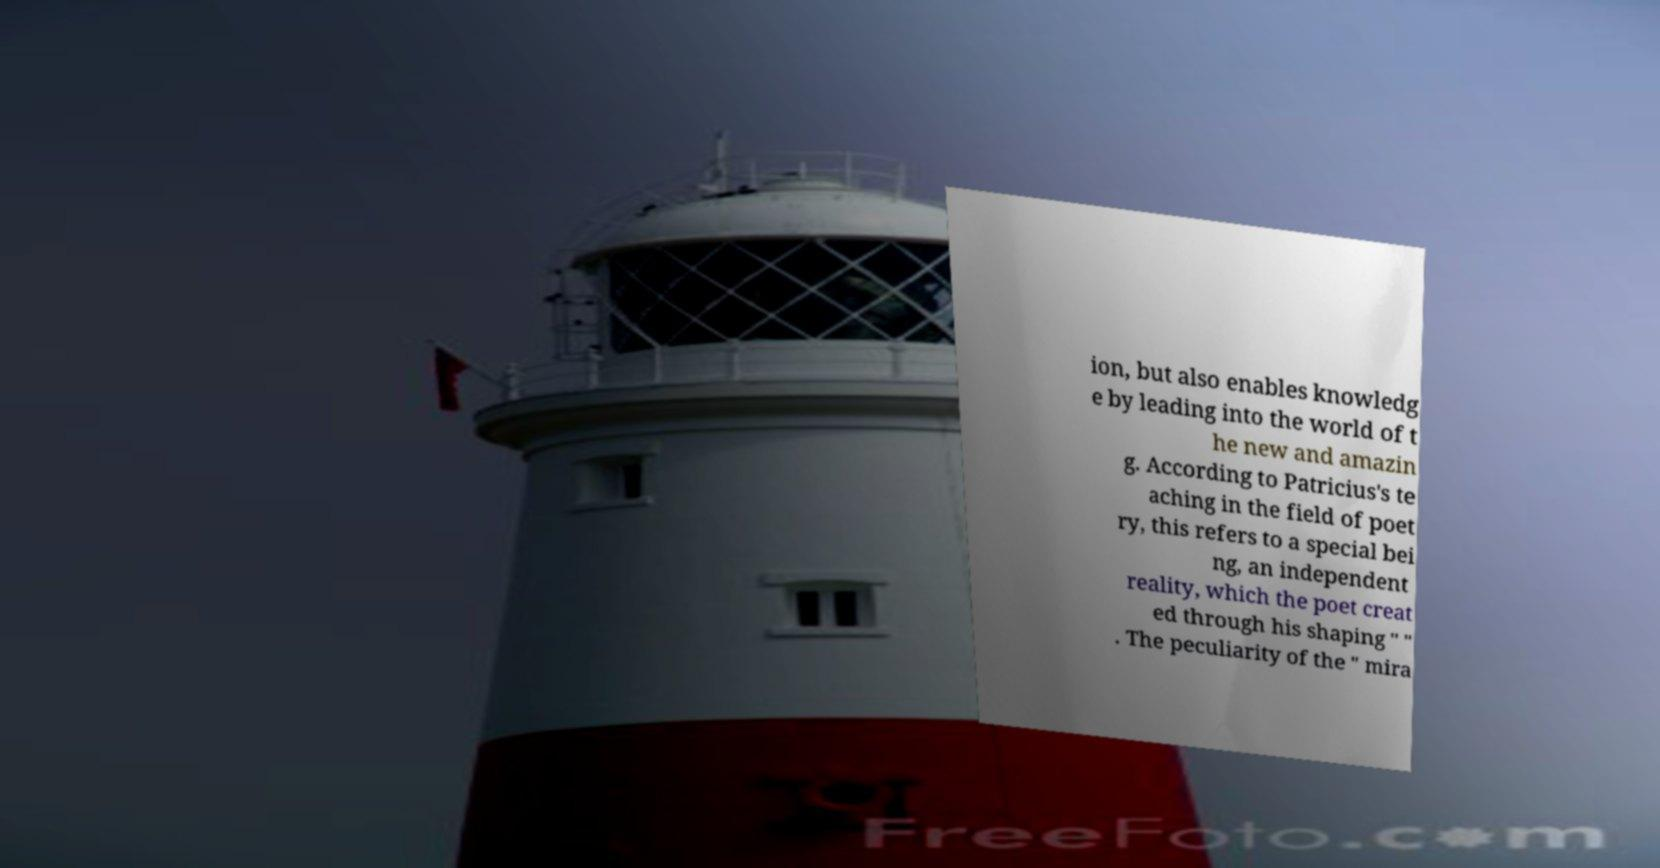What messages or text are displayed in this image? I need them in a readable, typed format. ion, but also enables knowledg e by leading into the world of t he new and amazin g. According to Patricius's te aching in the field of poet ry, this refers to a special bei ng, an independent reality, which the poet creat ed through his shaping " " . The peculiarity of the " mira 